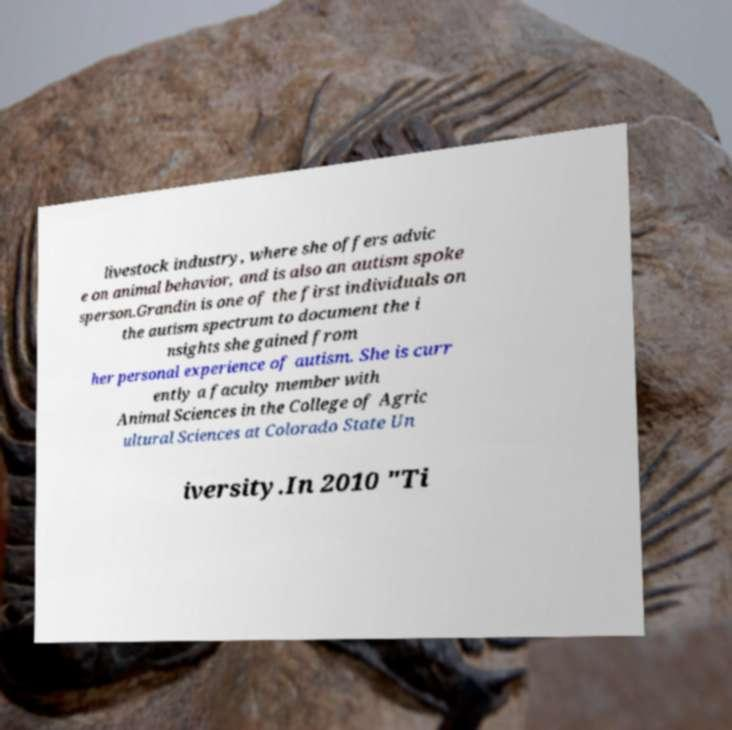I need the written content from this picture converted into text. Can you do that? livestock industry, where she offers advic e on animal behavior, and is also an autism spoke sperson.Grandin is one of the first individuals on the autism spectrum to document the i nsights she gained from her personal experience of autism. She is curr ently a faculty member with Animal Sciences in the College of Agric ultural Sciences at Colorado State Un iversity.In 2010 "Ti 